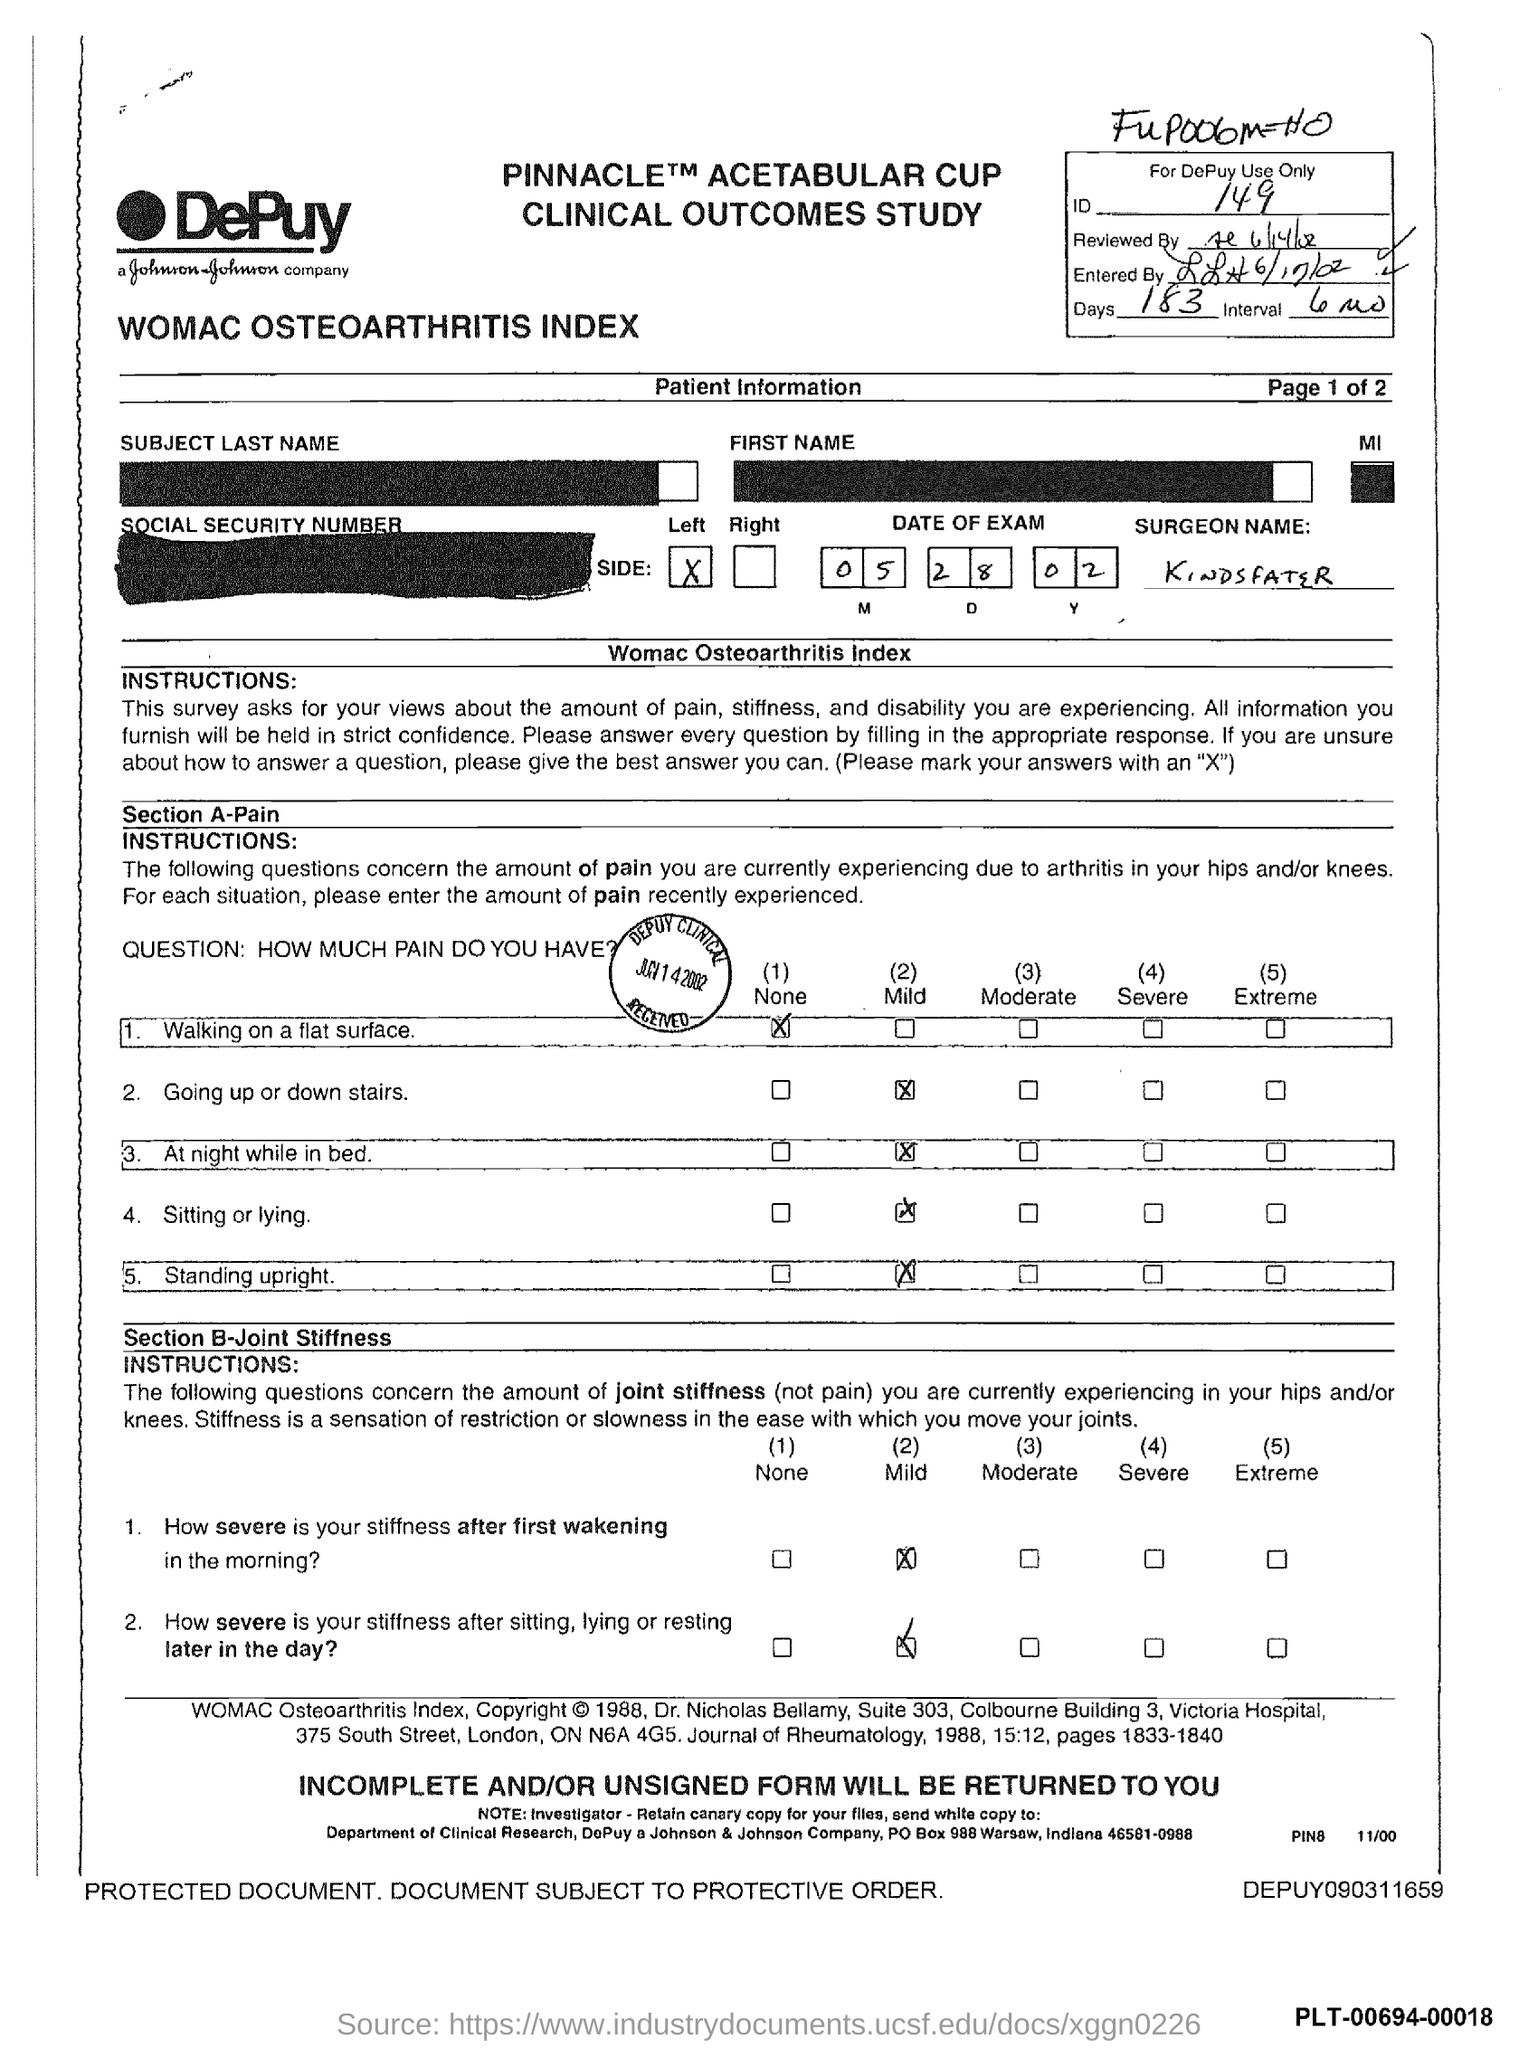Draw attention to some important aspects in this diagram. There are 183 days in the form. The interval period mentioned in the form is 6 months. The ID mentioned in the form is 149. The date of the exam as provided in the form is May 28, 2002. The surgeon's name mentioned in the form is "Kindsfater. 